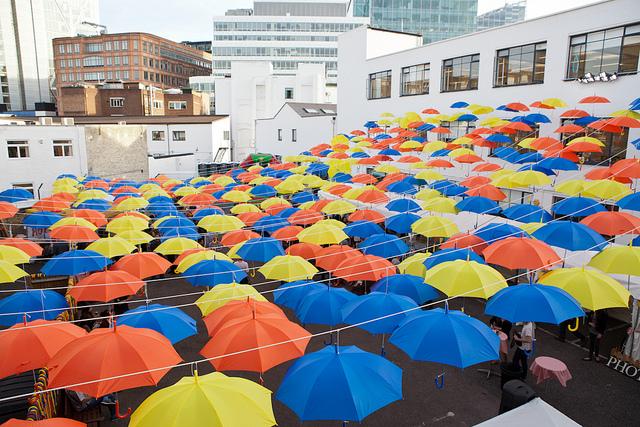Are the umbrellas planning on attacking?
Answer briefly. No. Is this outside or inside?
Give a very brief answer. Outside. How many blue umbrellas are there?
Short answer required. Many. 